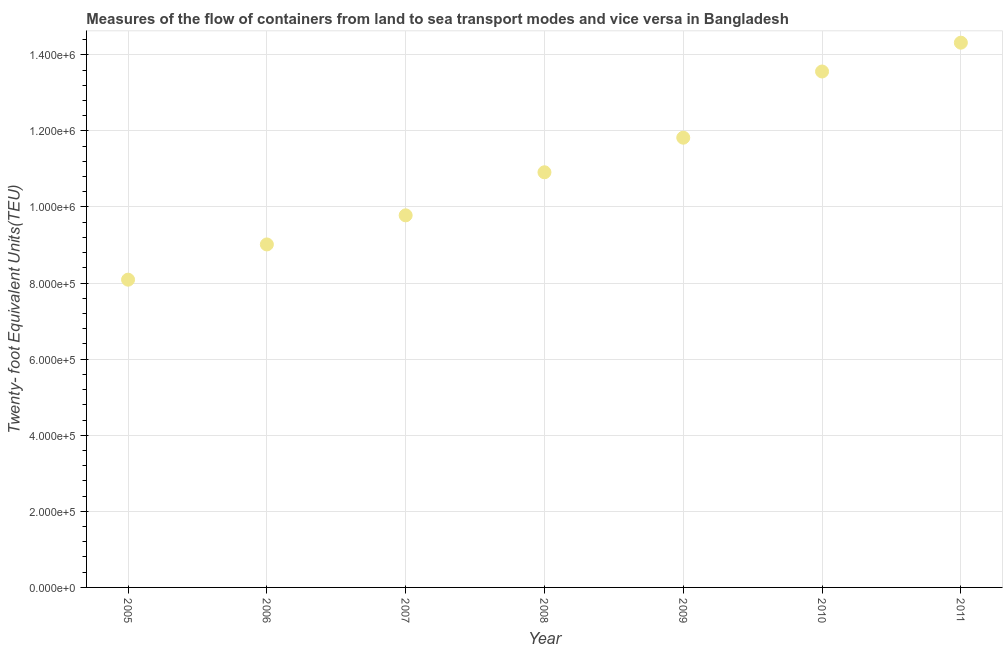What is the container port traffic in 2011?
Keep it short and to the point. 1.43e+06. Across all years, what is the maximum container port traffic?
Your answer should be very brief. 1.43e+06. Across all years, what is the minimum container port traffic?
Keep it short and to the point. 8.09e+05. In which year was the container port traffic maximum?
Your response must be concise. 2011. In which year was the container port traffic minimum?
Provide a succinct answer. 2005. What is the sum of the container port traffic?
Your answer should be compact. 7.75e+06. What is the difference between the container port traffic in 2010 and 2011?
Your response must be concise. -7.58e+04. What is the average container port traffic per year?
Offer a terse response. 1.11e+06. What is the median container port traffic?
Give a very brief answer. 1.09e+06. In how many years, is the container port traffic greater than 200000 TEU?
Give a very brief answer. 7. What is the ratio of the container port traffic in 2007 to that in 2008?
Your answer should be compact. 0.9. What is the difference between the highest and the second highest container port traffic?
Your response must be concise. 7.58e+04. What is the difference between the highest and the lowest container port traffic?
Offer a very short reply. 6.23e+05. How many dotlines are there?
Give a very brief answer. 1. How many years are there in the graph?
Provide a short and direct response. 7. What is the difference between two consecutive major ticks on the Y-axis?
Give a very brief answer. 2.00e+05. Are the values on the major ticks of Y-axis written in scientific E-notation?
Provide a short and direct response. Yes. Does the graph contain any zero values?
Provide a short and direct response. No. Does the graph contain grids?
Your response must be concise. Yes. What is the title of the graph?
Your answer should be compact. Measures of the flow of containers from land to sea transport modes and vice versa in Bangladesh. What is the label or title of the Y-axis?
Your answer should be very brief. Twenty- foot Equivalent Units(TEU). What is the Twenty- foot Equivalent Units(TEU) in 2005?
Your answer should be very brief. 8.09e+05. What is the Twenty- foot Equivalent Units(TEU) in 2006?
Offer a very short reply. 9.02e+05. What is the Twenty- foot Equivalent Units(TEU) in 2007?
Your answer should be very brief. 9.78e+05. What is the Twenty- foot Equivalent Units(TEU) in 2008?
Offer a very short reply. 1.09e+06. What is the Twenty- foot Equivalent Units(TEU) in 2009?
Provide a succinct answer. 1.18e+06. What is the Twenty- foot Equivalent Units(TEU) in 2010?
Keep it short and to the point. 1.36e+06. What is the Twenty- foot Equivalent Units(TEU) in 2011?
Provide a succinct answer. 1.43e+06. What is the difference between the Twenty- foot Equivalent Units(TEU) in 2005 and 2006?
Give a very brief answer. -9.26e+04. What is the difference between the Twenty- foot Equivalent Units(TEU) in 2005 and 2007?
Give a very brief answer. -1.69e+05. What is the difference between the Twenty- foot Equivalent Units(TEU) in 2005 and 2008?
Make the answer very short. -2.82e+05. What is the difference between the Twenty- foot Equivalent Units(TEU) in 2005 and 2009?
Offer a terse response. -3.73e+05. What is the difference between the Twenty- foot Equivalent Units(TEU) in 2005 and 2010?
Give a very brief answer. -5.47e+05. What is the difference between the Twenty- foot Equivalent Units(TEU) in 2005 and 2011?
Offer a terse response. -6.23e+05. What is the difference between the Twenty- foot Equivalent Units(TEU) in 2006 and 2007?
Provide a short and direct response. -7.65e+04. What is the difference between the Twenty- foot Equivalent Units(TEU) in 2006 and 2008?
Give a very brief answer. -1.90e+05. What is the difference between the Twenty- foot Equivalent Units(TEU) in 2006 and 2009?
Offer a terse response. -2.81e+05. What is the difference between the Twenty- foot Equivalent Units(TEU) in 2006 and 2010?
Provide a succinct answer. -4.55e+05. What is the difference between the Twenty- foot Equivalent Units(TEU) in 2006 and 2011?
Provide a succinct answer. -5.30e+05. What is the difference between the Twenty- foot Equivalent Units(TEU) in 2007 and 2008?
Make the answer very short. -1.13e+05. What is the difference between the Twenty- foot Equivalent Units(TEU) in 2007 and 2009?
Your answer should be compact. -2.04e+05. What is the difference between the Twenty- foot Equivalent Units(TEU) in 2007 and 2010?
Make the answer very short. -3.78e+05. What is the difference between the Twenty- foot Equivalent Units(TEU) in 2007 and 2011?
Your answer should be very brief. -4.54e+05. What is the difference between the Twenty- foot Equivalent Units(TEU) in 2008 and 2009?
Provide a short and direct response. -9.09e+04. What is the difference between the Twenty- foot Equivalent Units(TEU) in 2008 and 2010?
Your answer should be compact. -2.65e+05. What is the difference between the Twenty- foot Equivalent Units(TEU) in 2008 and 2011?
Offer a terse response. -3.41e+05. What is the difference between the Twenty- foot Equivalent Units(TEU) in 2009 and 2010?
Provide a short and direct response. -1.74e+05. What is the difference between the Twenty- foot Equivalent Units(TEU) in 2009 and 2011?
Give a very brief answer. -2.50e+05. What is the difference between the Twenty- foot Equivalent Units(TEU) in 2010 and 2011?
Give a very brief answer. -7.58e+04. What is the ratio of the Twenty- foot Equivalent Units(TEU) in 2005 to that in 2006?
Make the answer very short. 0.9. What is the ratio of the Twenty- foot Equivalent Units(TEU) in 2005 to that in 2007?
Ensure brevity in your answer.  0.83. What is the ratio of the Twenty- foot Equivalent Units(TEU) in 2005 to that in 2008?
Your answer should be very brief. 0.74. What is the ratio of the Twenty- foot Equivalent Units(TEU) in 2005 to that in 2009?
Keep it short and to the point. 0.68. What is the ratio of the Twenty- foot Equivalent Units(TEU) in 2005 to that in 2010?
Provide a succinct answer. 0.6. What is the ratio of the Twenty- foot Equivalent Units(TEU) in 2005 to that in 2011?
Provide a short and direct response. 0.56. What is the ratio of the Twenty- foot Equivalent Units(TEU) in 2006 to that in 2007?
Offer a terse response. 0.92. What is the ratio of the Twenty- foot Equivalent Units(TEU) in 2006 to that in 2008?
Offer a very short reply. 0.83. What is the ratio of the Twenty- foot Equivalent Units(TEU) in 2006 to that in 2009?
Provide a succinct answer. 0.76. What is the ratio of the Twenty- foot Equivalent Units(TEU) in 2006 to that in 2010?
Offer a terse response. 0.67. What is the ratio of the Twenty- foot Equivalent Units(TEU) in 2006 to that in 2011?
Make the answer very short. 0.63. What is the ratio of the Twenty- foot Equivalent Units(TEU) in 2007 to that in 2008?
Your response must be concise. 0.9. What is the ratio of the Twenty- foot Equivalent Units(TEU) in 2007 to that in 2009?
Keep it short and to the point. 0.83. What is the ratio of the Twenty- foot Equivalent Units(TEU) in 2007 to that in 2010?
Your response must be concise. 0.72. What is the ratio of the Twenty- foot Equivalent Units(TEU) in 2007 to that in 2011?
Give a very brief answer. 0.68. What is the ratio of the Twenty- foot Equivalent Units(TEU) in 2008 to that in 2009?
Provide a short and direct response. 0.92. What is the ratio of the Twenty- foot Equivalent Units(TEU) in 2008 to that in 2010?
Your answer should be compact. 0.81. What is the ratio of the Twenty- foot Equivalent Units(TEU) in 2008 to that in 2011?
Your answer should be very brief. 0.76. What is the ratio of the Twenty- foot Equivalent Units(TEU) in 2009 to that in 2010?
Your answer should be very brief. 0.87. What is the ratio of the Twenty- foot Equivalent Units(TEU) in 2009 to that in 2011?
Make the answer very short. 0.83. What is the ratio of the Twenty- foot Equivalent Units(TEU) in 2010 to that in 2011?
Your answer should be very brief. 0.95. 